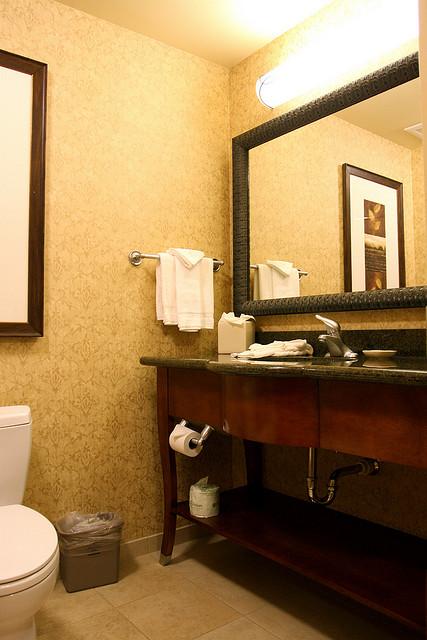What color are the towels?
Short answer required. White. What might you do in this room?
Answer briefly. Use toilet. Is the trash can empty?
Concise answer only. No. What color is the sink?
Quick response, please. Black. 